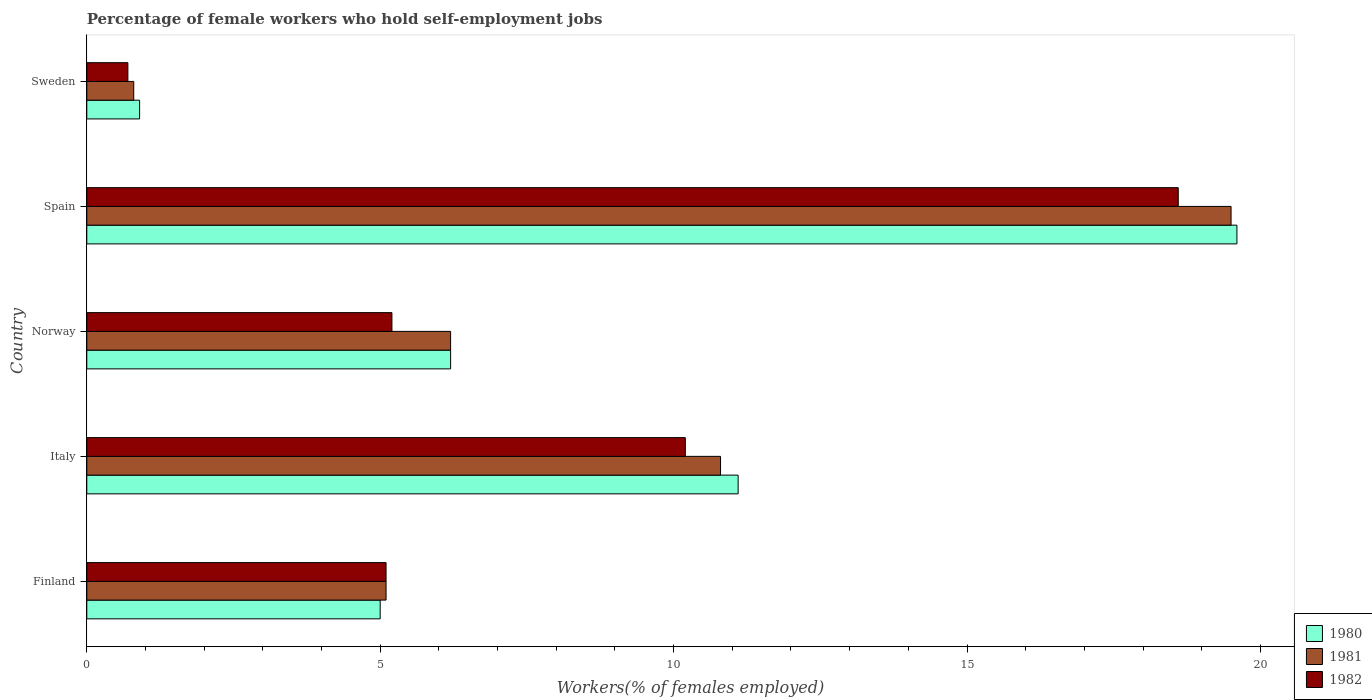Are the number of bars per tick equal to the number of legend labels?
Give a very brief answer. Yes. Are the number of bars on each tick of the Y-axis equal?
Your answer should be compact. Yes. How many bars are there on the 5th tick from the top?
Keep it short and to the point. 3. What is the label of the 1st group of bars from the top?
Offer a very short reply. Sweden. What is the percentage of self-employed female workers in 1982 in Spain?
Make the answer very short. 18.6. Across all countries, what is the maximum percentage of self-employed female workers in 1980?
Your answer should be compact. 19.6. Across all countries, what is the minimum percentage of self-employed female workers in 1980?
Your answer should be compact. 0.9. What is the total percentage of self-employed female workers in 1980 in the graph?
Your answer should be very brief. 42.8. What is the difference between the percentage of self-employed female workers in 1981 in Italy and that in Sweden?
Offer a terse response. 10. What is the difference between the percentage of self-employed female workers in 1981 in Spain and the percentage of self-employed female workers in 1982 in Sweden?
Your answer should be compact. 18.8. What is the average percentage of self-employed female workers in 1980 per country?
Offer a terse response. 8.56. What is the difference between the percentage of self-employed female workers in 1980 and percentage of self-employed female workers in 1981 in Finland?
Provide a succinct answer. -0.1. What is the ratio of the percentage of self-employed female workers in 1980 in Italy to that in Spain?
Your answer should be very brief. 0.57. Is the percentage of self-employed female workers in 1982 in Finland less than that in Sweden?
Provide a short and direct response. No. What is the difference between the highest and the second highest percentage of self-employed female workers in 1982?
Ensure brevity in your answer.  8.4. What is the difference between the highest and the lowest percentage of self-employed female workers in 1982?
Your response must be concise. 17.9. In how many countries, is the percentage of self-employed female workers in 1980 greater than the average percentage of self-employed female workers in 1980 taken over all countries?
Make the answer very short. 2. What does the 3rd bar from the top in Norway represents?
Offer a very short reply. 1980. How many bars are there?
Make the answer very short. 15. What is the difference between two consecutive major ticks on the X-axis?
Provide a succinct answer. 5. Are the values on the major ticks of X-axis written in scientific E-notation?
Make the answer very short. No. Does the graph contain any zero values?
Offer a very short reply. No. Does the graph contain grids?
Give a very brief answer. No. Where does the legend appear in the graph?
Your answer should be compact. Bottom right. How many legend labels are there?
Make the answer very short. 3. How are the legend labels stacked?
Provide a succinct answer. Vertical. What is the title of the graph?
Offer a terse response. Percentage of female workers who hold self-employment jobs. Does "1999" appear as one of the legend labels in the graph?
Ensure brevity in your answer.  No. What is the label or title of the X-axis?
Provide a succinct answer. Workers(% of females employed). What is the Workers(% of females employed) of 1981 in Finland?
Your answer should be compact. 5.1. What is the Workers(% of females employed) of 1982 in Finland?
Offer a very short reply. 5.1. What is the Workers(% of females employed) of 1980 in Italy?
Give a very brief answer. 11.1. What is the Workers(% of females employed) of 1981 in Italy?
Keep it short and to the point. 10.8. What is the Workers(% of females employed) in 1982 in Italy?
Your answer should be compact. 10.2. What is the Workers(% of females employed) in 1980 in Norway?
Offer a terse response. 6.2. What is the Workers(% of females employed) in 1981 in Norway?
Provide a short and direct response. 6.2. What is the Workers(% of females employed) of 1982 in Norway?
Ensure brevity in your answer.  5.2. What is the Workers(% of females employed) in 1980 in Spain?
Make the answer very short. 19.6. What is the Workers(% of females employed) in 1982 in Spain?
Your answer should be compact. 18.6. What is the Workers(% of females employed) in 1980 in Sweden?
Ensure brevity in your answer.  0.9. What is the Workers(% of females employed) in 1981 in Sweden?
Your answer should be very brief. 0.8. What is the Workers(% of females employed) of 1982 in Sweden?
Your response must be concise. 0.7. Across all countries, what is the maximum Workers(% of females employed) of 1980?
Your answer should be compact. 19.6. Across all countries, what is the maximum Workers(% of females employed) of 1982?
Provide a short and direct response. 18.6. Across all countries, what is the minimum Workers(% of females employed) in 1980?
Your response must be concise. 0.9. Across all countries, what is the minimum Workers(% of females employed) of 1981?
Your answer should be very brief. 0.8. Across all countries, what is the minimum Workers(% of females employed) of 1982?
Offer a very short reply. 0.7. What is the total Workers(% of females employed) in 1980 in the graph?
Make the answer very short. 42.8. What is the total Workers(% of females employed) in 1981 in the graph?
Provide a succinct answer. 42.4. What is the total Workers(% of females employed) of 1982 in the graph?
Your answer should be very brief. 39.8. What is the difference between the Workers(% of females employed) in 1980 in Finland and that in Italy?
Provide a succinct answer. -6.1. What is the difference between the Workers(% of females employed) of 1981 in Finland and that in Italy?
Provide a short and direct response. -5.7. What is the difference between the Workers(% of females employed) of 1982 in Finland and that in Italy?
Your answer should be very brief. -5.1. What is the difference between the Workers(% of females employed) of 1980 in Finland and that in Norway?
Offer a very short reply. -1.2. What is the difference between the Workers(% of females employed) in 1980 in Finland and that in Spain?
Keep it short and to the point. -14.6. What is the difference between the Workers(% of females employed) in 1981 in Finland and that in Spain?
Your response must be concise. -14.4. What is the difference between the Workers(% of females employed) in 1980 in Finland and that in Sweden?
Provide a short and direct response. 4.1. What is the difference between the Workers(% of females employed) of 1981 in Finland and that in Sweden?
Provide a short and direct response. 4.3. What is the difference between the Workers(% of females employed) of 1982 in Finland and that in Sweden?
Keep it short and to the point. 4.4. What is the difference between the Workers(% of females employed) of 1982 in Italy and that in Norway?
Your response must be concise. 5. What is the difference between the Workers(% of females employed) in 1980 in Italy and that in Spain?
Give a very brief answer. -8.5. What is the difference between the Workers(% of females employed) of 1981 in Italy and that in Spain?
Offer a terse response. -8.7. What is the difference between the Workers(% of females employed) in 1982 in Italy and that in Spain?
Provide a short and direct response. -8.4. What is the difference between the Workers(% of females employed) in 1980 in Italy and that in Sweden?
Offer a terse response. 10.2. What is the difference between the Workers(% of females employed) of 1980 in Norway and that in Spain?
Your answer should be compact. -13.4. What is the difference between the Workers(% of females employed) of 1981 in Norway and that in Spain?
Provide a succinct answer. -13.3. What is the difference between the Workers(% of females employed) in 1982 in Norway and that in Spain?
Make the answer very short. -13.4. What is the difference between the Workers(% of females employed) in 1980 in Norway and that in Sweden?
Keep it short and to the point. 5.3. What is the difference between the Workers(% of females employed) in 1981 in Norway and that in Sweden?
Make the answer very short. 5.4. What is the difference between the Workers(% of females employed) of 1982 in Norway and that in Sweden?
Keep it short and to the point. 4.5. What is the difference between the Workers(% of females employed) of 1980 in Spain and that in Sweden?
Offer a terse response. 18.7. What is the difference between the Workers(% of females employed) in 1981 in Spain and that in Sweden?
Your answer should be compact. 18.7. What is the difference between the Workers(% of females employed) of 1981 in Finland and the Workers(% of females employed) of 1982 in Italy?
Offer a very short reply. -5.1. What is the difference between the Workers(% of females employed) of 1980 in Finland and the Workers(% of females employed) of 1982 in Sweden?
Give a very brief answer. 4.3. What is the difference between the Workers(% of females employed) of 1981 in Finland and the Workers(% of females employed) of 1982 in Sweden?
Your answer should be compact. 4.4. What is the difference between the Workers(% of females employed) of 1980 in Italy and the Workers(% of females employed) of 1981 in Spain?
Your response must be concise. -8.4. What is the difference between the Workers(% of females employed) in 1981 in Italy and the Workers(% of females employed) in 1982 in Sweden?
Provide a succinct answer. 10.1. What is the difference between the Workers(% of females employed) in 1980 in Norway and the Workers(% of females employed) in 1982 in Spain?
Offer a terse response. -12.4. What is the difference between the Workers(% of females employed) in 1981 in Norway and the Workers(% of females employed) in 1982 in Spain?
Keep it short and to the point. -12.4. What is the difference between the Workers(% of females employed) of 1980 in Norway and the Workers(% of females employed) of 1982 in Sweden?
Provide a succinct answer. 5.5. What is the average Workers(% of females employed) in 1980 per country?
Provide a succinct answer. 8.56. What is the average Workers(% of females employed) of 1981 per country?
Provide a short and direct response. 8.48. What is the average Workers(% of females employed) in 1982 per country?
Your answer should be very brief. 7.96. What is the difference between the Workers(% of females employed) in 1980 and Workers(% of females employed) in 1982 in Finland?
Your answer should be compact. -0.1. What is the difference between the Workers(% of females employed) of 1980 and Workers(% of females employed) of 1981 in Italy?
Provide a short and direct response. 0.3. What is the difference between the Workers(% of females employed) in 1980 and Workers(% of females employed) in 1982 in Italy?
Provide a succinct answer. 0.9. What is the difference between the Workers(% of females employed) of 1981 and Workers(% of females employed) of 1982 in Italy?
Make the answer very short. 0.6. What is the difference between the Workers(% of females employed) of 1980 and Workers(% of females employed) of 1982 in Spain?
Keep it short and to the point. 1. What is the difference between the Workers(% of females employed) in 1980 and Workers(% of females employed) in 1981 in Sweden?
Provide a short and direct response. 0.1. What is the difference between the Workers(% of females employed) of 1980 and Workers(% of females employed) of 1982 in Sweden?
Ensure brevity in your answer.  0.2. What is the difference between the Workers(% of females employed) in 1981 and Workers(% of females employed) in 1982 in Sweden?
Offer a very short reply. 0.1. What is the ratio of the Workers(% of females employed) in 1980 in Finland to that in Italy?
Your answer should be compact. 0.45. What is the ratio of the Workers(% of females employed) in 1981 in Finland to that in Italy?
Offer a terse response. 0.47. What is the ratio of the Workers(% of females employed) of 1982 in Finland to that in Italy?
Give a very brief answer. 0.5. What is the ratio of the Workers(% of females employed) of 1980 in Finland to that in Norway?
Offer a very short reply. 0.81. What is the ratio of the Workers(% of females employed) in 1981 in Finland to that in Norway?
Provide a short and direct response. 0.82. What is the ratio of the Workers(% of females employed) of 1982 in Finland to that in Norway?
Your answer should be compact. 0.98. What is the ratio of the Workers(% of females employed) of 1980 in Finland to that in Spain?
Provide a short and direct response. 0.26. What is the ratio of the Workers(% of females employed) of 1981 in Finland to that in Spain?
Offer a terse response. 0.26. What is the ratio of the Workers(% of females employed) of 1982 in Finland to that in Spain?
Ensure brevity in your answer.  0.27. What is the ratio of the Workers(% of females employed) of 1980 in Finland to that in Sweden?
Provide a short and direct response. 5.56. What is the ratio of the Workers(% of females employed) in 1981 in Finland to that in Sweden?
Ensure brevity in your answer.  6.38. What is the ratio of the Workers(% of females employed) in 1982 in Finland to that in Sweden?
Keep it short and to the point. 7.29. What is the ratio of the Workers(% of females employed) in 1980 in Italy to that in Norway?
Provide a short and direct response. 1.79. What is the ratio of the Workers(% of females employed) in 1981 in Italy to that in Norway?
Ensure brevity in your answer.  1.74. What is the ratio of the Workers(% of females employed) of 1982 in Italy to that in Norway?
Give a very brief answer. 1.96. What is the ratio of the Workers(% of females employed) of 1980 in Italy to that in Spain?
Your answer should be very brief. 0.57. What is the ratio of the Workers(% of females employed) in 1981 in Italy to that in Spain?
Your answer should be compact. 0.55. What is the ratio of the Workers(% of females employed) in 1982 in Italy to that in Spain?
Keep it short and to the point. 0.55. What is the ratio of the Workers(% of females employed) in 1980 in Italy to that in Sweden?
Your answer should be very brief. 12.33. What is the ratio of the Workers(% of females employed) of 1982 in Italy to that in Sweden?
Give a very brief answer. 14.57. What is the ratio of the Workers(% of females employed) of 1980 in Norway to that in Spain?
Offer a terse response. 0.32. What is the ratio of the Workers(% of females employed) in 1981 in Norway to that in Spain?
Offer a terse response. 0.32. What is the ratio of the Workers(% of females employed) in 1982 in Norway to that in Spain?
Offer a very short reply. 0.28. What is the ratio of the Workers(% of females employed) in 1980 in Norway to that in Sweden?
Give a very brief answer. 6.89. What is the ratio of the Workers(% of females employed) of 1981 in Norway to that in Sweden?
Provide a succinct answer. 7.75. What is the ratio of the Workers(% of females employed) in 1982 in Norway to that in Sweden?
Your response must be concise. 7.43. What is the ratio of the Workers(% of females employed) of 1980 in Spain to that in Sweden?
Make the answer very short. 21.78. What is the ratio of the Workers(% of females employed) in 1981 in Spain to that in Sweden?
Your response must be concise. 24.38. What is the ratio of the Workers(% of females employed) in 1982 in Spain to that in Sweden?
Your response must be concise. 26.57. What is the difference between the highest and the second highest Workers(% of females employed) of 1981?
Your response must be concise. 8.7. What is the difference between the highest and the lowest Workers(% of females employed) of 1981?
Keep it short and to the point. 18.7. What is the difference between the highest and the lowest Workers(% of females employed) in 1982?
Your answer should be very brief. 17.9. 